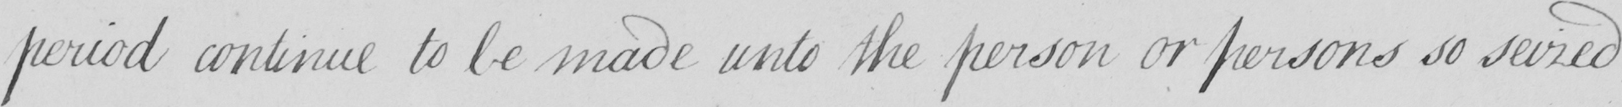What does this handwritten line say? period continue to be made unto the person or persons so seized 